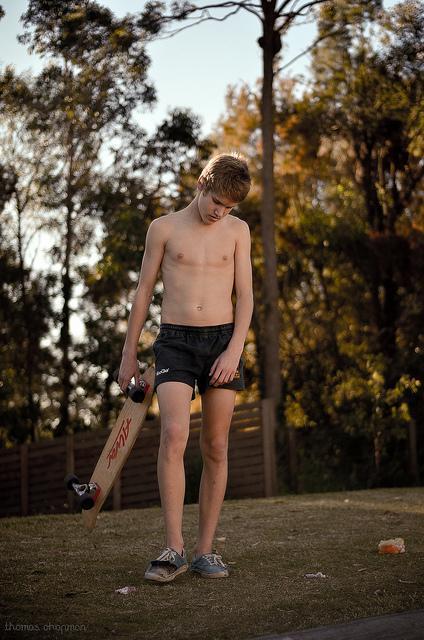How many skateboards are in the picture?
Give a very brief answer. 1. How many skis is the boy holding?
Give a very brief answer. 0. 